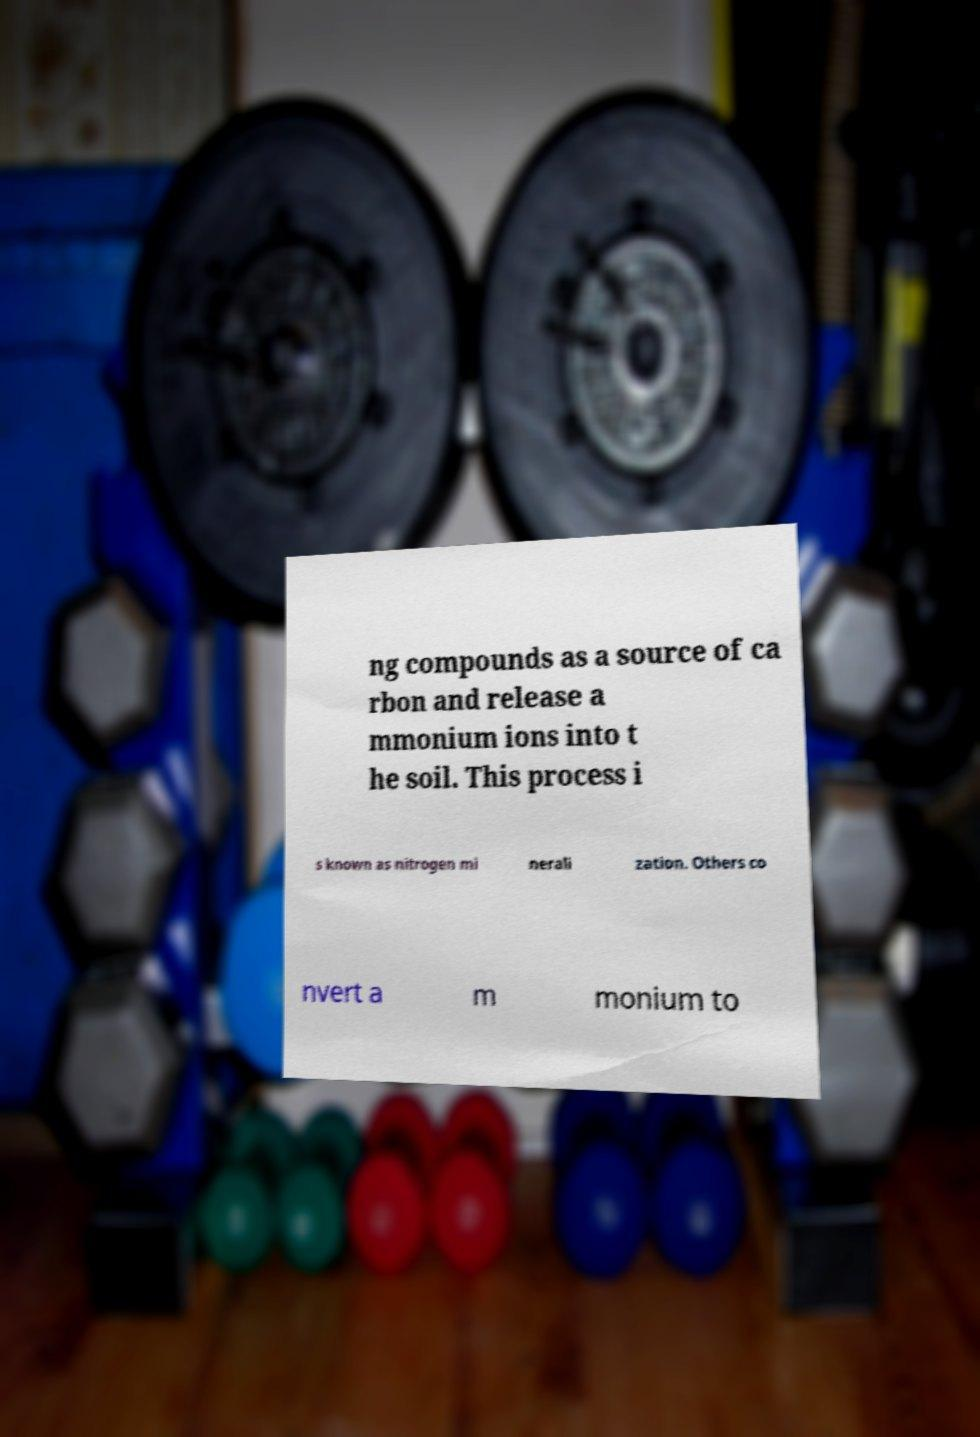For documentation purposes, I need the text within this image transcribed. Could you provide that? ng compounds as a source of ca rbon and release a mmonium ions into t he soil. This process i s known as nitrogen mi nerali zation. Others co nvert a m monium to 